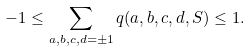Convert formula to latex. <formula><loc_0><loc_0><loc_500><loc_500>- 1 \leq \sum _ { a , b , c , d = \pm 1 } q ( a , b , c , d , S ) \leq 1 .</formula> 